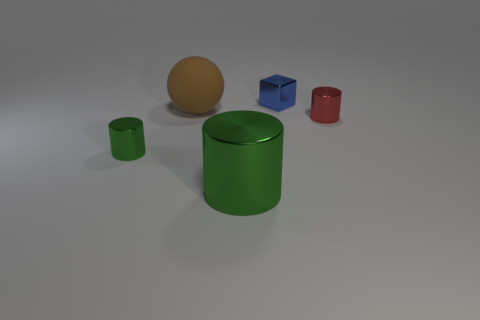Could you tell a story about how the different objects ended up in this arrangement? Certainly, imagine a craftsperson testing various materials and shapes for a new art installation. They arranged these pieces randomly on a table after examining their reflectivity and textural contrasts under a careful array of lights to determine their visual appeal for the final piece. 